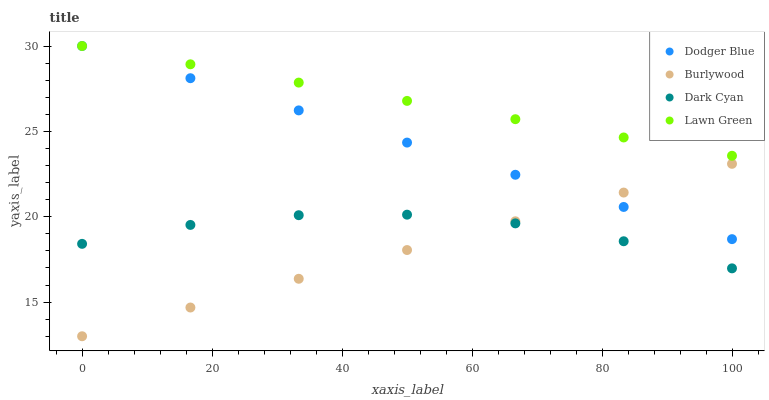Does Burlywood have the minimum area under the curve?
Answer yes or no. Yes. Does Lawn Green have the maximum area under the curve?
Answer yes or no. Yes. Does Dark Cyan have the minimum area under the curve?
Answer yes or no. No. Does Dark Cyan have the maximum area under the curve?
Answer yes or no. No. Is Burlywood the smoothest?
Answer yes or no. Yes. Is Dark Cyan the roughest?
Answer yes or no. Yes. Is Dodger Blue the smoothest?
Answer yes or no. No. Is Dodger Blue the roughest?
Answer yes or no. No. Does Burlywood have the lowest value?
Answer yes or no. Yes. Does Dark Cyan have the lowest value?
Answer yes or no. No. Does Lawn Green have the highest value?
Answer yes or no. Yes. Does Dark Cyan have the highest value?
Answer yes or no. No. Is Burlywood less than Lawn Green?
Answer yes or no. Yes. Is Dodger Blue greater than Dark Cyan?
Answer yes or no. Yes. Does Dodger Blue intersect Burlywood?
Answer yes or no. Yes. Is Dodger Blue less than Burlywood?
Answer yes or no. No. Is Dodger Blue greater than Burlywood?
Answer yes or no. No. Does Burlywood intersect Lawn Green?
Answer yes or no. No. 